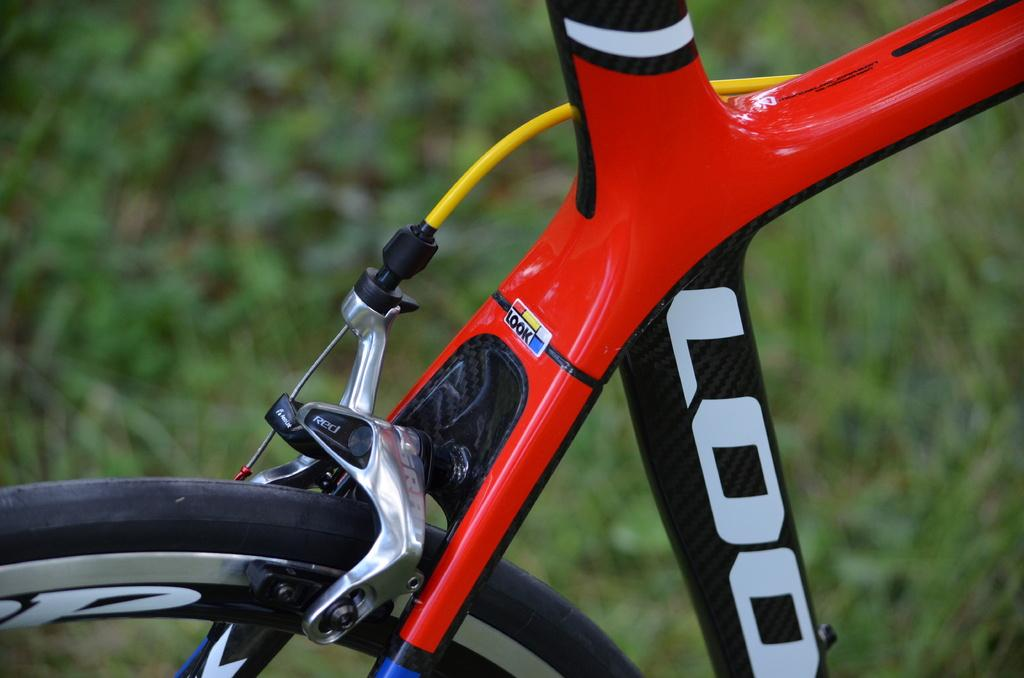What object related to transportation can be seen in the image? There is a part of a bicycle in the image. Can you describe the background of the image? The background of the image is blurred. What type of wine is being served in the image? There is no wine present in the image; it features a part of a bicycle and a blurred background. 